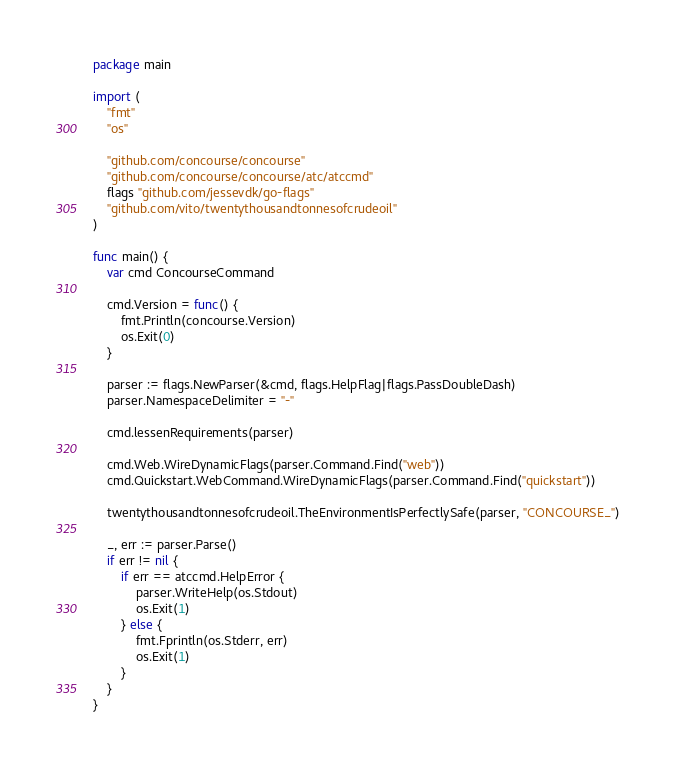<code> <loc_0><loc_0><loc_500><loc_500><_Go_>package main

import (
	"fmt"
	"os"

	"github.com/concourse/concourse"
	"github.com/concourse/concourse/atc/atccmd"
	flags "github.com/jessevdk/go-flags"
	"github.com/vito/twentythousandtonnesofcrudeoil"
)

func main() {
	var cmd ConcourseCommand

	cmd.Version = func() {
		fmt.Println(concourse.Version)
		os.Exit(0)
	}

	parser := flags.NewParser(&cmd, flags.HelpFlag|flags.PassDoubleDash)
	parser.NamespaceDelimiter = "-"

	cmd.lessenRequirements(parser)

	cmd.Web.WireDynamicFlags(parser.Command.Find("web"))
	cmd.Quickstart.WebCommand.WireDynamicFlags(parser.Command.Find("quickstart"))

	twentythousandtonnesofcrudeoil.TheEnvironmentIsPerfectlySafe(parser, "CONCOURSE_")

	_, err := parser.Parse()
	if err != nil {
		if err == atccmd.HelpError {
			parser.WriteHelp(os.Stdout)
			os.Exit(1)
		} else {
			fmt.Fprintln(os.Stderr, err)
			os.Exit(1)
		}
	}
}
</code> 